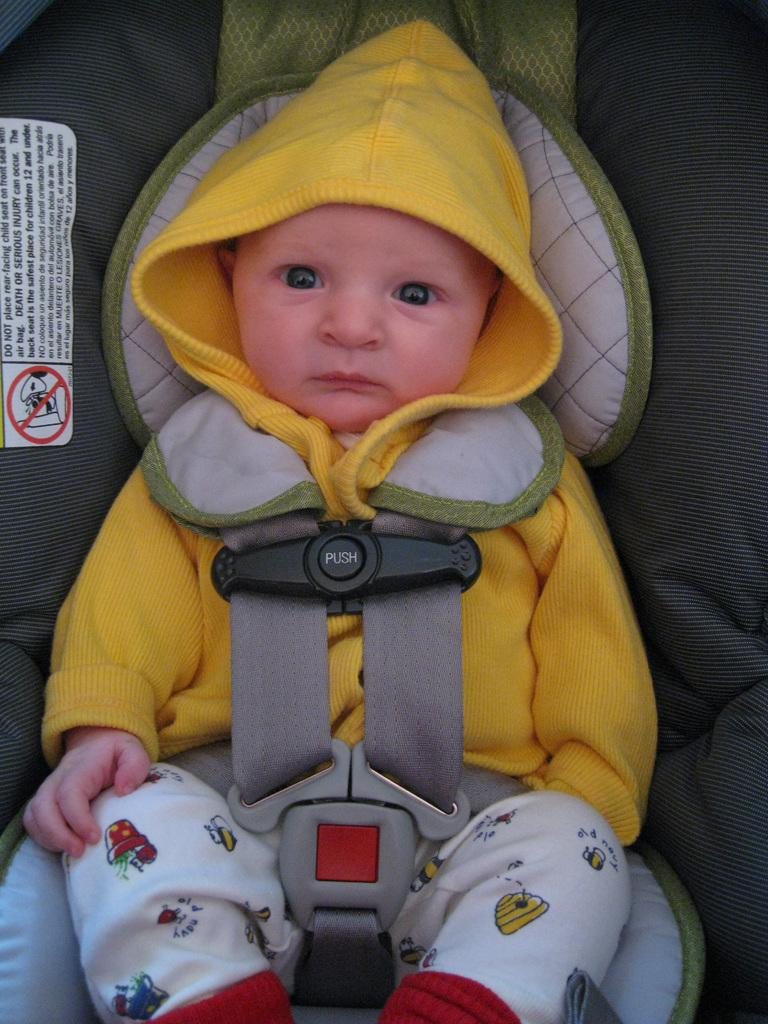Who is the main subject in the picture? There is a boy in the picture. What is the boy wearing? The boy is wearing a yellow hoodie and white trousers. What is the boy doing in the picture? The boy is sitting on a trolley. What type of club does the boy belong to in the picture? There is no indication in the picture that the boy belongs to any club. 